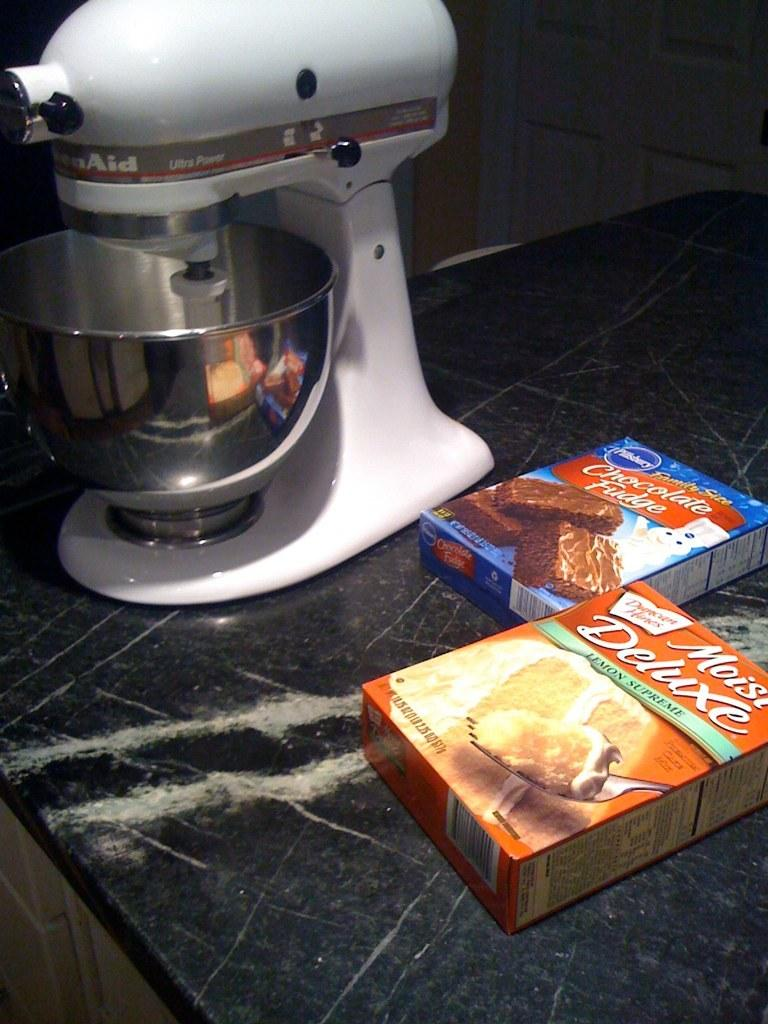<image>
Relay a brief, clear account of the picture shown. a mixer with boxes of Moist Deluxe and Chocolate Fudge next to it 